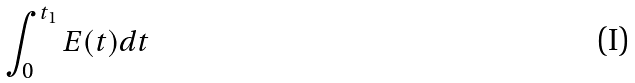Convert formula to latex. <formula><loc_0><loc_0><loc_500><loc_500>\int _ { 0 } ^ { t _ { 1 } } E ( t ) d t</formula> 